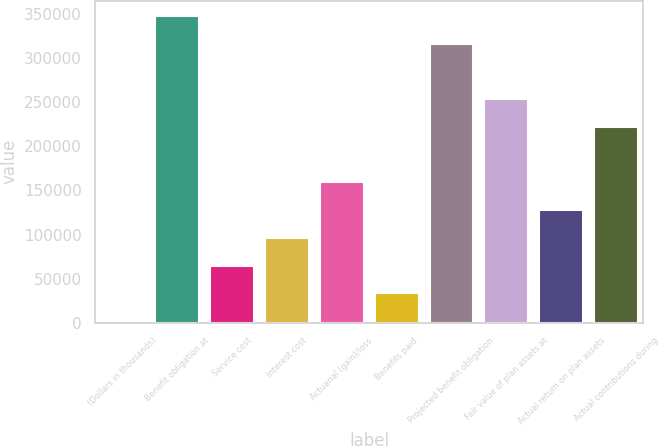Convert chart to OTSL. <chart><loc_0><loc_0><loc_500><loc_500><bar_chart><fcel>(Dollars in thousands)<fcel>Benefit obligation at<fcel>Service cost<fcel>Interest cost<fcel>Actuarial (gain)/loss<fcel>Benefits paid<fcel>Projected benefit obligation<fcel>Fair value of plan assets at<fcel>Actual return on plan assets<fcel>Actual contributions during<nl><fcel>2018<fcel>347620<fcel>64854.8<fcel>96273.2<fcel>159110<fcel>33436.4<fcel>316202<fcel>253365<fcel>127692<fcel>221947<nl></chart> 